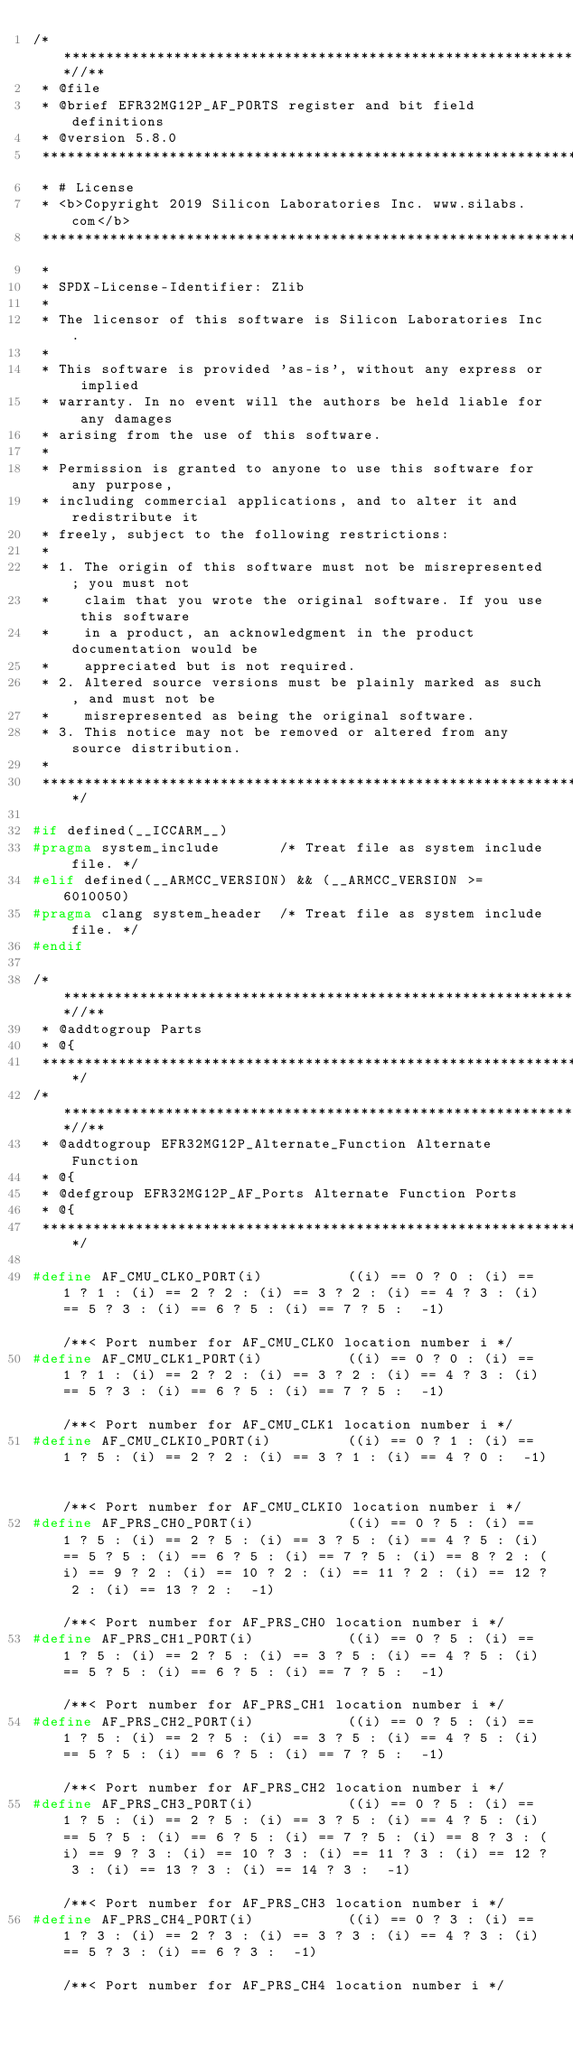Convert code to text. <code><loc_0><loc_0><loc_500><loc_500><_C_>/***************************************************************************//**
 * @file
 * @brief EFR32MG12P_AF_PORTS register and bit field definitions
 * @version 5.8.0
 *******************************************************************************
 * # License
 * <b>Copyright 2019 Silicon Laboratories Inc. www.silabs.com</b>
 *******************************************************************************
 *
 * SPDX-License-Identifier: Zlib
 *
 * The licensor of this software is Silicon Laboratories Inc.
 *
 * This software is provided 'as-is', without any express or implied
 * warranty. In no event will the authors be held liable for any damages
 * arising from the use of this software.
 *
 * Permission is granted to anyone to use this software for any purpose,
 * including commercial applications, and to alter it and redistribute it
 * freely, subject to the following restrictions:
 *
 * 1. The origin of this software must not be misrepresented; you must not
 *    claim that you wrote the original software. If you use this software
 *    in a product, an acknowledgment in the product documentation would be
 *    appreciated but is not required.
 * 2. Altered source versions must be plainly marked as such, and must not be
 *    misrepresented as being the original software.
 * 3. This notice may not be removed or altered from any source distribution.
 *
 ******************************************************************************/

#if defined(__ICCARM__)
#pragma system_include       /* Treat file as system include file. */
#elif defined(__ARMCC_VERSION) && (__ARMCC_VERSION >= 6010050)
#pragma clang system_header  /* Treat file as system include file. */
#endif

/***************************************************************************//**
 * @addtogroup Parts
 * @{
 ******************************************************************************/
/***************************************************************************//**
 * @addtogroup EFR32MG12P_Alternate_Function Alternate Function
 * @{
 * @defgroup EFR32MG12P_AF_Ports Alternate Function Ports
 * @{
 ******************************************************************************/

#define AF_CMU_CLK0_PORT(i)          ((i) == 0 ? 0 : (i) == 1 ? 1 : (i) == 2 ? 2 : (i) == 3 ? 2 : (i) == 4 ? 3 : (i) == 5 ? 3 : (i) == 6 ? 5 : (i) == 7 ? 5 :  -1)                                                                                                                                                                                                                                                                                                                                                                                                  /**< Port number for AF_CMU_CLK0 location number i */
#define AF_CMU_CLK1_PORT(i)          ((i) == 0 ? 0 : (i) == 1 ? 1 : (i) == 2 ? 2 : (i) == 3 ? 2 : (i) == 4 ? 3 : (i) == 5 ? 3 : (i) == 6 ? 5 : (i) == 7 ? 5 :  -1)                                                                                                                                                                                                                                                                                                                                                                                                  /**< Port number for AF_CMU_CLK1 location number i */
#define AF_CMU_CLKI0_PORT(i)         ((i) == 0 ? 1 : (i) == 1 ? 5 : (i) == 2 ? 2 : (i) == 3 ? 1 : (i) == 4 ? 0 :  -1)                                                                                                                                                                                                                                                                                                                                                                                                                                               /**< Port number for AF_CMU_CLKI0 location number i */
#define AF_PRS_CH0_PORT(i)           ((i) == 0 ? 5 : (i) == 1 ? 5 : (i) == 2 ? 5 : (i) == 3 ? 5 : (i) == 4 ? 5 : (i) == 5 ? 5 : (i) == 6 ? 5 : (i) == 7 ? 5 : (i) == 8 ? 2 : (i) == 9 ? 2 : (i) == 10 ? 2 : (i) == 11 ? 2 : (i) == 12 ? 2 : (i) == 13 ? 2 :  -1)                                                                                                                                                                                                                                                                                                    /**< Port number for AF_PRS_CH0 location number i */
#define AF_PRS_CH1_PORT(i)           ((i) == 0 ? 5 : (i) == 1 ? 5 : (i) == 2 ? 5 : (i) == 3 ? 5 : (i) == 4 ? 5 : (i) == 5 ? 5 : (i) == 6 ? 5 : (i) == 7 ? 5 :  -1)                                                                                                                                                                                                                                                                                                                                                                                                  /**< Port number for AF_PRS_CH1 location number i */
#define AF_PRS_CH2_PORT(i)           ((i) == 0 ? 5 : (i) == 1 ? 5 : (i) == 2 ? 5 : (i) == 3 ? 5 : (i) == 4 ? 5 : (i) == 5 ? 5 : (i) == 6 ? 5 : (i) == 7 ? 5 :  -1)                                                                                                                                                                                                                                                                                                                                                                                                  /**< Port number for AF_PRS_CH2 location number i */
#define AF_PRS_CH3_PORT(i)           ((i) == 0 ? 5 : (i) == 1 ? 5 : (i) == 2 ? 5 : (i) == 3 ? 5 : (i) == 4 ? 5 : (i) == 5 ? 5 : (i) == 6 ? 5 : (i) == 7 ? 5 : (i) == 8 ? 3 : (i) == 9 ? 3 : (i) == 10 ? 3 : (i) == 11 ? 3 : (i) == 12 ? 3 : (i) == 13 ? 3 : (i) == 14 ? 3 :  -1)                                                                                                                                                                                                                                                                                    /**< Port number for AF_PRS_CH3 location number i */
#define AF_PRS_CH4_PORT(i)           ((i) == 0 ? 3 : (i) == 1 ? 3 : (i) == 2 ? 3 : (i) == 3 ? 3 : (i) == 4 ? 3 : (i) == 5 ? 3 : (i) == 6 ? 3 :  -1)                                                                                                                                                                                                                                                                                                                                                                                                                 /**< Port number for AF_PRS_CH4 location number i */</code> 